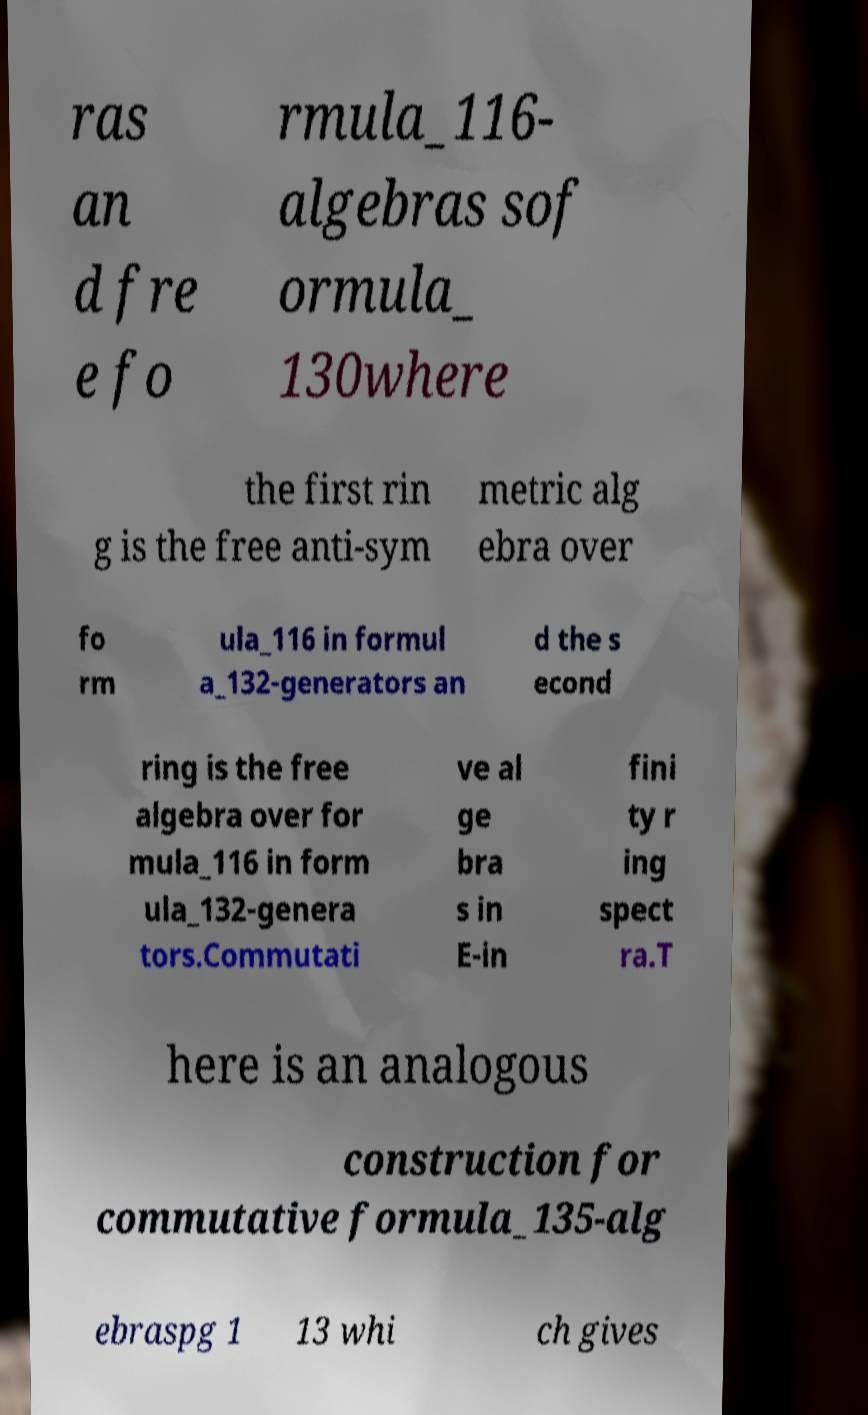For documentation purposes, I need the text within this image transcribed. Could you provide that? ras an d fre e fo rmula_116- algebras sof ormula_ 130where the first rin g is the free anti-sym metric alg ebra over fo rm ula_116 in formul a_132-generators an d the s econd ring is the free algebra over for mula_116 in form ula_132-genera tors.Commutati ve al ge bra s in E-in fini ty r ing spect ra.T here is an analogous construction for commutative formula_135-alg ebraspg 1 13 whi ch gives 